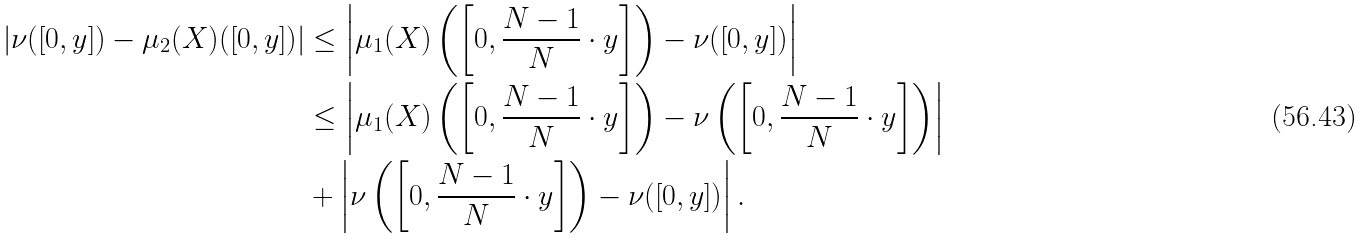Convert formula to latex. <formula><loc_0><loc_0><loc_500><loc_500>\left | \nu ( [ 0 , y ] ) - \mu _ { 2 } ( X ) ( [ 0 , y ] ) \right | & \leq \left | \mu _ { 1 } ( X ) \left ( \left [ 0 , \frac { N - 1 } { N } \cdot y \right ] \right ) - \nu ( [ 0 , y ] ) \right | \\ & \leq \left | \mu _ { 1 } ( X ) \left ( \left [ 0 , \frac { N - 1 } { N } \cdot y \right ] \right ) - \nu \left ( \left [ 0 , \frac { N - 1 } { N } \cdot y \right ] \right ) \right | \\ & + \left | \nu \left ( \left [ 0 , \frac { N - 1 } { N } \cdot y \right ] \right ) - \nu ( [ 0 , y ] ) \right | .</formula> 